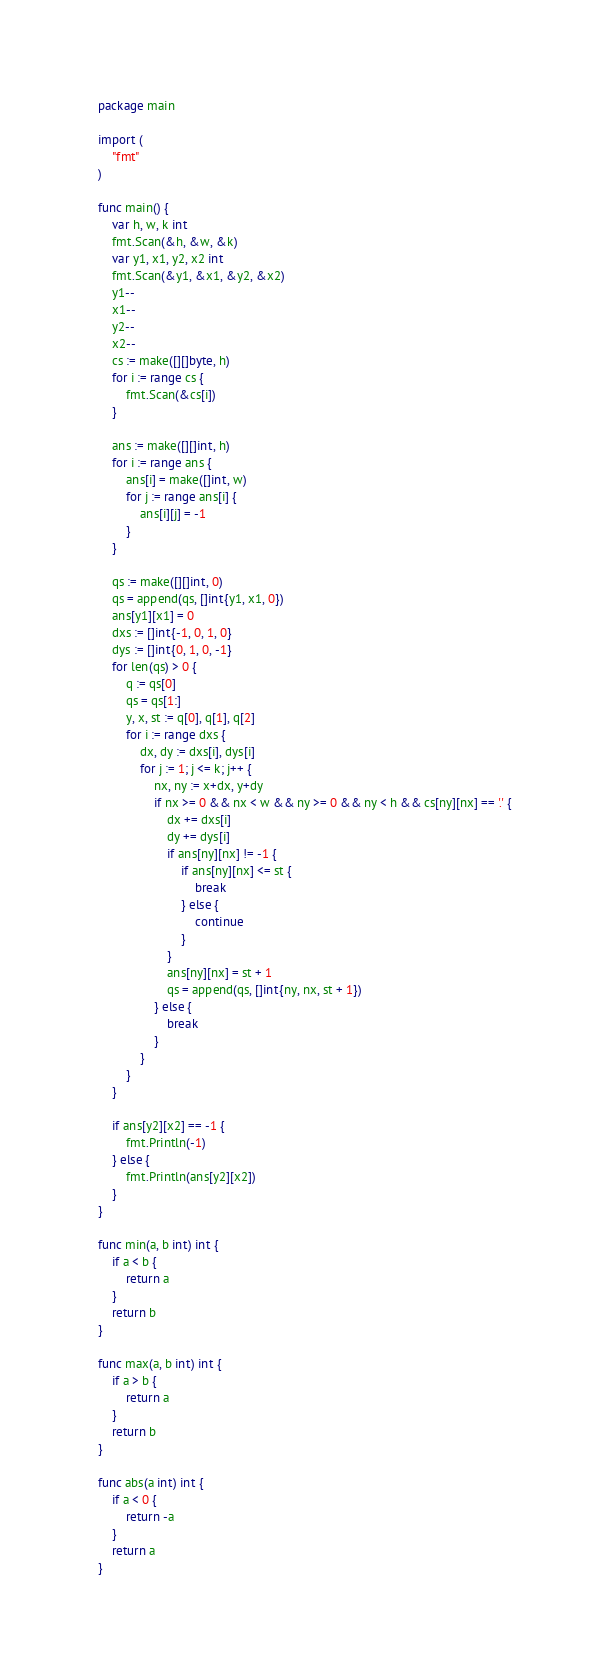<code> <loc_0><loc_0><loc_500><loc_500><_Go_>package main

import (
	"fmt"
)

func main() {
	var h, w, k int
	fmt.Scan(&h, &w, &k)
	var y1, x1, y2, x2 int
	fmt.Scan(&y1, &x1, &y2, &x2)
	y1--
	x1--
	y2--
	x2--
	cs := make([][]byte, h)
	for i := range cs {
		fmt.Scan(&cs[i])
	}

	ans := make([][]int, h)
	for i := range ans {
		ans[i] = make([]int, w)
		for j := range ans[i] {
			ans[i][j] = -1
		}
	}

	qs := make([][]int, 0)
	qs = append(qs, []int{y1, x1, 0})
	ans[y1][x1] = 0
	dxs := []int{-1, 0, 1, 0}
	dys := []int{0, 1, 0, -1}
	for len(qs) > 0 {
		q := qs[0]
		qs = qs[1:]
		y, x, st := q[0], q[1], q[2]
		for i := range dxs {
			dx, dy := dxs[i], dys[i]
			for j := 1; j <= k; j++ {
				nx, ny := x+dx, y+dy
				if nx >= 0 && nx < w && ny >= 0 && ny < h && cs[ny][nx] == '.' {
					dx += dxs[i]
					dy += dys[i]
					if ans[ny][nx] != -1 {
						if ans[ny][nx] <= st {
							break
						} else {
							continue
						}
					}
					ans[ny][nx] = st + 1
					qs = append(qs, []int{ny, nx, st + 1})
				} else {
					break
				}
			}
		}
	}

	if ans[y2][x2] == -1 {
		fmt.Println(-1)
	} else {
		fmt.Println(ans[y2][x2])
	}
}

func min(a, b int) int {
	if a < b {
		return a
	}
	return b
}

func max(a, b int) int {
	if a > b {
		return a
	}
	return b
}

func abs(a int) int {
	if a < 0 {
		return -a
	}
	return a
}
</code> 